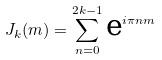Convert formula to latex. <formula><loc_0><loc_0><loc_500><loc_500>J _ { k } ( m ) = \sum _ { n = 0 } ^ { 2 k - 1 } \text {e} ^ { i \pi n m }</formula> 